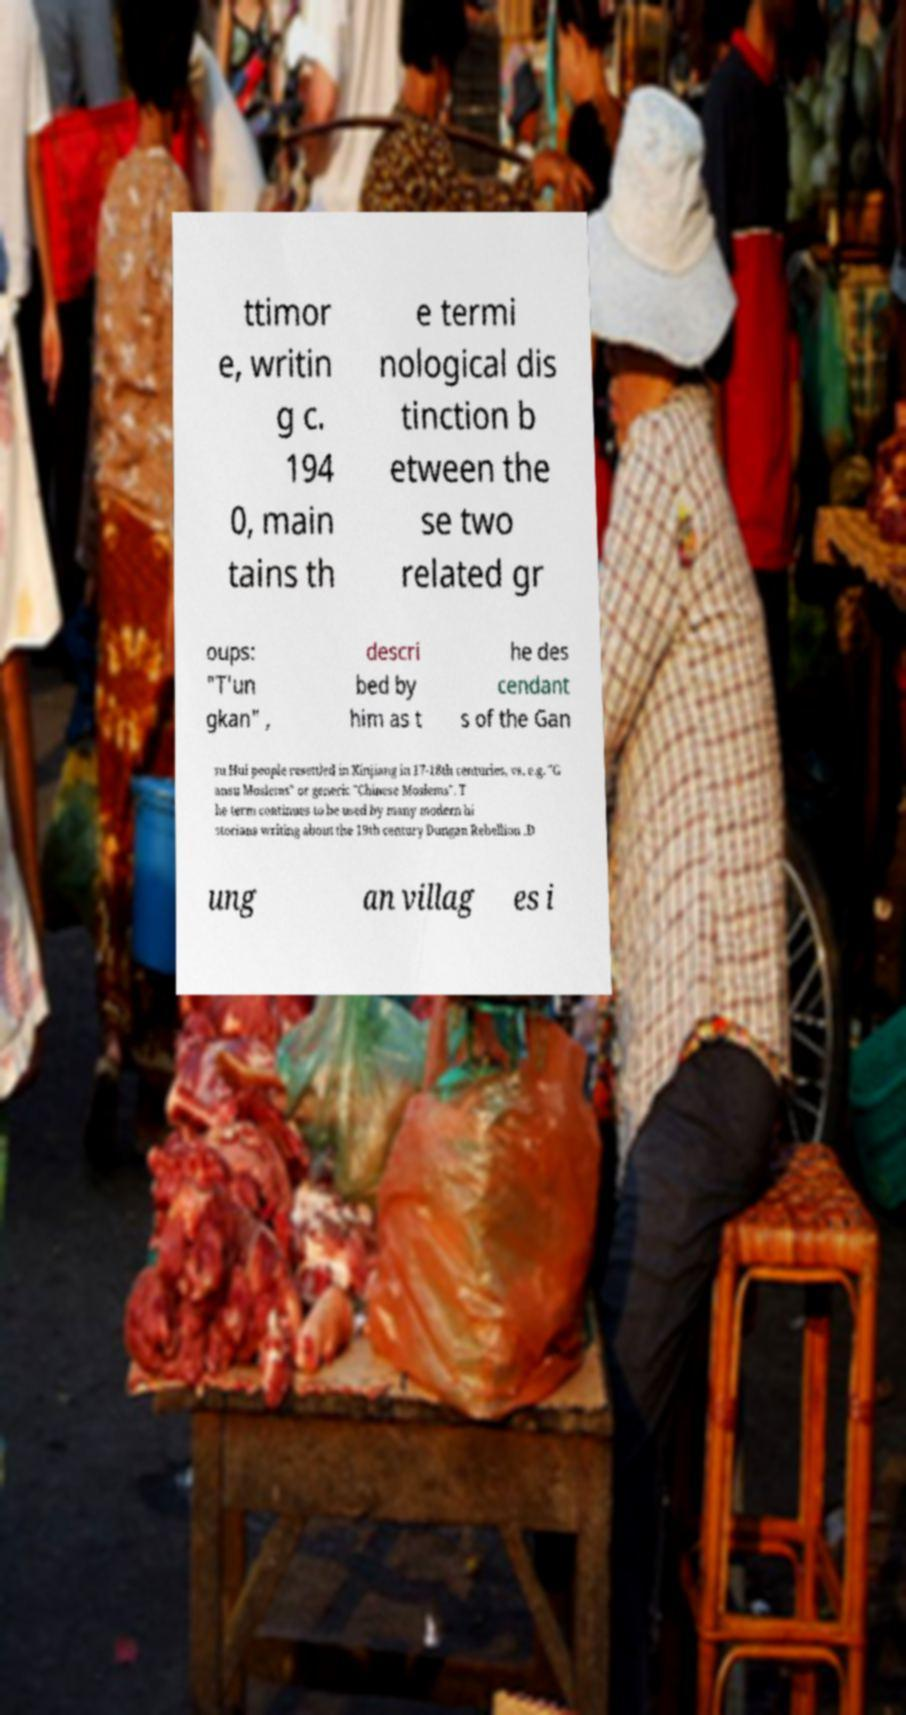Can you read and provide the text displayed in the image?This photo seems to have some interesting text. Can you extract and type it out for me? ttimor e, writin g c. 194 0, main tains th e termi nological dis tinction b etween the se two related gr oups: "T'un gkan" , descri bed by him as t he des cendant s of the Gan su Hui people resettled in Xinjiang in 17-18th centuries, vs. e.g. "G ansu Moslems" or generic "Chinese Moslems". T he term continues to be used by many modern hi storians writing about the 19th century Dungan Rebellion .D ung an villag es i 